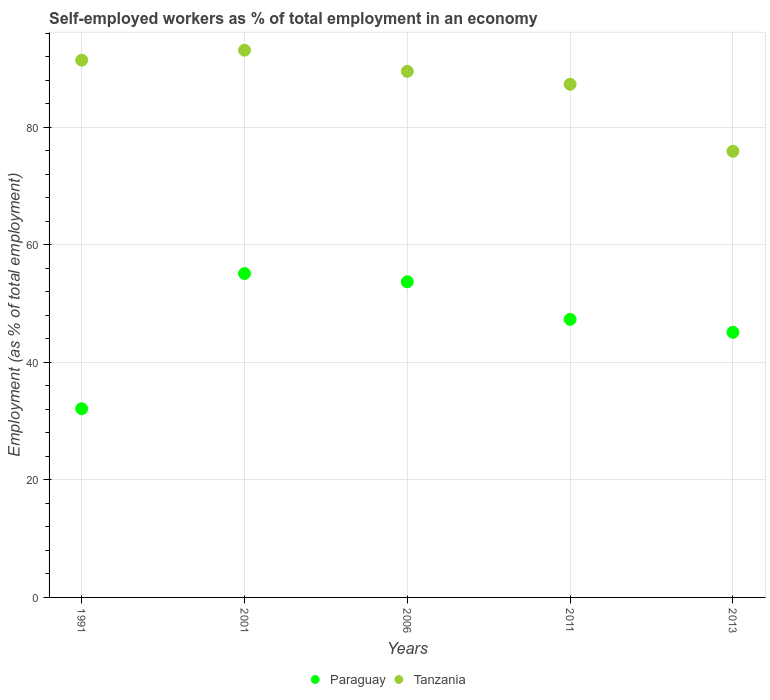Is the number of dotlines equal to the number of legend labels?
Provide a succinct answer. Yes. What is the percentage of self-employed workers in Tanzania in 2013?
Provide a succinct answer. 75.9. Across all years, what is the maximum percentage of self-employed workers in Paraguay?
Your response must be concise. 55.1. Across all years, what is the minimum percentage of self-employed workers in Paraguay?
Provide a succinct answer. 32.1. In which year was the percentage of self-employed workers in Tanzania maximum?
Keep it short and to the point. 2001. In which year was the percentage of self-employed workers in Paraguay minimum?
Make the answer very short. 1991. What is the total percentage of self-employed workers in Tanzania in the graph?
Provide a succinct answer. 437.2. What is the difference between the percentage of self-employed workers in Paraguay in 2011 and the percentage of self-employed workers in Tanzania in 2013?
Offer a terse response. -28.6. What is the average percentage of self-employed workers in Tanzania per year?
Your answer should be compact. 87.44. In the year 2011, what is the difference between the percentage of self-employed workers in Tanzania and percentage of self-employed workers in Paraguay?
Give a very brief answer. 40. In how many years, is the percentage of self-employed workers in Tanzania greater than 88 %?
Keep it short and to the point. 3. What is the ratio of the percentage of self-employed workers in Tanzania in 2001 to that in 2006?
Your answer should be compact. 1.04. Is the percentage of self-employed workers in Tanzania in 1991 less than that in 2013?
Your answer should be compact. No. What is the difference between the highest and the second highest percentage of self-employed workers in Tanzania?
Give a very brief answer. 1.7. What is the difference between the highest and the lowest percentage of self-employed workers in Paraguay?
Make the answer very short. 23. Is the sum of the percentage of self-employed workers in Tanzania in 2001 and 2011 greater than the maximum percentage of self-employed workers in Paraguay across all years?
Offer a very short reply. Yes. Does the percentage of self-employed workers in Paraguay monotonically increase over the years?
Ensure brevity in your answer.  No. Is the percentage of self-employed workers in Paraguay strictly greater than the percentage of self-employed workers in Tanzania over the years?
Your answer should be compact. No. Is the percentage of self-employed workers in Tanzania strictly less than the percentage of self-employed workers in Paraguay over the years?
Your answer should be compact. No. How many dotlines are there?
Ensure brevity in your answer.  2. How many years are there in the graph?
Give a very brief answer. 5. What is the difference between two consecutive major ticks on the Y-axis?
Make the answer very short. 20. Does the graph contain any zero values?
Provide a short and direct response. No. Does the graph contain grids?
Make the answer very short. Yes. How many legend labels are there?
Your answer should be compact. 2. What is the title of the graph?
Offer a very short reply. Self-employed workers as % of total employment in an economy. Does "Israel" appear as one of the legend labels in the graph?
Ensure brevity in your answer.  No. What is the label or title of the X-axis?
Make the answer very short. Years. What is the label or title of the Y-axis?
Your answer should be very brief. Employment (as % of total employment). What is the Employment (as % of total employment) in Paraguay in 1991?
Ensure brevity in your answer.  32.1. What is the Employment (as % of total employment) of Tanzania in 1991?
Provide a succinct answer. 91.4. What is the Employment (as % of total employment) of Paraguay in 2001?
Keep it short and to the point. 55.1. What is the Employment (as % of total employment) of Tanzania in 2001?
Your answer should be very brief. 93.1. What is the Employment (as % of total employment) of Paraguay in 2006?
Your answer should be very brief. 53.7. What is the Employment (as % of total employment) in Tanzania in 2006?
Provide a short and direct response. 89.5. What is the Employment (as % of total employment) of Paraguay in 2011?
Ensure brevity in your answer.  47.3. What is the Employment (as % of total employment) in Tanzania in 2011?
Your response must be concise. 87.3. What is the Employment (as % of total employment) of Paraguay in 2013?
Your response must be concise. 45.1. What is the Employment (as % of total employment) of Tanzania in 2013?
Provide a short and direct response. 75.9. Across all years, what is the maximum Employment (as % of total employment) in Paraguay?
Your answer should be very brief. 55.1. Across all years, what is the maximum Employment (as % of total employment) of Tanzania?
Your answer should be compact. 93.1. Across all years, what is the minimum Employment (as % of total employment) of Paraguay?
Give a very brief answer. 32.1. Across all years, what is the minimum Employment (as % of total employment) of Tanzania?
Make the answer very short. 75.9. What is the total Employment (as % of total employment) in Paraguay in the graph?
Make the answer very short. 233.3. What is the total Employment (as % of total employment) of Tanzania in the graph?
Offer a terse response. 437.2. What is the difference between the Employment (as % of total employment) in Paraguay in 1991 and that in 2001?
Provide a short and direct response. -23. What is the difference between the Employment (as % of total employment) in Tanzania in 1991 and that in 2001?
Keep it short and to the point. -1.7. What is the difference between the Employment (as % of total employment) in Paraguay in 1991 and that in 2006?
Your answer should be very brief. -21.6. What is the difference between the Employment (as % of total employment) of Tanzania in 1991 and that in 2006?
Provide a short and direct response. 1.9. What is the difference between the Employment (as % of total employment) of Paraguay in 1991 and that in 2011?
Your answer should be compact. -15.2. What is the difference between the Employment (as % of total employment) in Tanzania in 1991 and that in 2011?
Provide a short and direct response. 4.1. What is the difference between the Employment (as % of total employment) in Paraguay in 1991 and that in 2013?
Your answer should be very brief. -13. What is the difference between the Employment (as % of total employment) of Tanzania in 1991 and that in 2013?
Provide a succinct answer. 15.5. What is the difference between the Employment (as % of total employment) of Paraguay in 2001 and that in 2006?
Offer a terse response. 1.4. What is the difference between the Employment (as % of total employment) of Paraguay in 2001 and that in 2011?
Give a very brief answer. 7.8. What is the difference between the Employment (as % of total employment) in Tanzania in 2001 and that in 2011?
Offer a terse response. 5.8. What is the difference between the Employment (as % of total employment) of Tanzania in 2001 and that in 2013?
Your answer should be compact. 17.2. What is the difference between the Employment (as % of total employment) in Paraguay in 2006 and that in 2011?
Provide a short and direct response. 6.4. What is the difference between the Employment (as % of total employment) of Paraguay in 2006 and that in 2013?
Make the answer very short. 8.6. What is the difference between the Employment (as % of total employment) in Tanzania in 2006 and that in 2013?
Make the answer very short. 13.6. What is the difference between the Employment (as % of total employment) of Paraguay in 2011 and that in 2013?
Your response must be concise. 2.2. What is the difference between the Employment (as % of total employment) in Paraguay in 1991 and the Employment (as % of total employment) in Tanzania in 2001?
Your response must be concise. -61. What is the difference between the Employment (as % of total employment) in Paraguay in 1991 and the Employment (as % of total employment) in Tanzania in 2006?
Ensure brevity in your answer.  -57.4. What is the difference between the Employment (as % of total employment) of Paraguay in 1991 and the Employment (as % of total employment) of Tanzania in 2011?
Offer a very short reply. -55.2. What is the difference between the Employment (as % of total employment) in Paraguay in 1991 and the Employment (as % of total employment) in Tanzania in 2013?
Provide a short and direct response. -43.8. What is the difference between the Employment (as % of total employment) of Paraguay in 2001 and the Employment (as % of total employment) of Tanzania in 2006?
Make the answer very short. -34.4. What is the difference between the Employment (as % of total employment) of Paraguay in 2001 and the Employment (as % of total employment) of Tanzania in 2011?
Offer a very short reply. -32.2. What is the difference between the Employment (as % of total employment) in Paraguay in 2001 and the Employment (as % of total employment) in Tanzania in 2013?
Provide a succinct answer. -20.8. What is the difference between the Employment (as % of total employment) of Paraguay in 2006 and the Employment (as % of total employment) of Tanzania in 2011?
Offer a very short reply. -33.6. What is the difference between the Employment (as % of total employment) of Paraguay in 2006 and the Employment (as % of total employment) of Tanzania in 2013?
Your answer should be very brief. -22.2. What is the difference between the Employment (as % of total employment) of Paraguay in 2011 and the Employment (as % of total employment) of Tanzania in 2013?
Offer a very short reply. -28.6. What is the average Employment (as % of total employment) in Paraguay per year?
Keep it short and to the point. 46.66. What is the average Employment (as % of total employment) of Tanzania per year?
Offer a very short reply. 87.44. In the year 1991, what is the difference between the Employment (as % of total employment) of Paraguay and Employment (as % of total employment) of Tanzania?
Offer a terse response. -59.3. In the year 2001, what is the difference between the Employment (as % of total employment) in Paraguay and Employment (as % of total employment) in Tanzania?
Ensure brevity in your answer.  -38. In the year 2006, what is the difference between the Employment (as % of total employment) in Paraguay and Employment (as % of total employment) in Tanzania?
Your answer should be compact. -35.8. In the year 2013, what is the difference between the Employment (as % of total employment) in Paraguay and Employment (as % of total employment) in Tanzania?
Offer a very short reply. -30.8. What is the ratio of the Employment (as % of total employment) of Paraguay in 1991 to that in 2001?
Offer a terse response. 0.58. What is the ratio of the Employment (as % of total employment) in Tanzania in 1991 to that in 2001?
Your answer should be very brief. 0.98. What is the ratio of the Employment (as % of total employment) of Paraguay in 1991 to that in 2006?
Your answer should be compact. 0.6. What is the ratio of the Employment (as % of total employment) in Tanzania in 1991 to that in 2006?
Your response must be concise. 1.02. What is the ratio of the Employment (as % of total employment) in Paraguay in 1991 to that in 2011?
Make the answer very short. 0.68. What is the ratio of the Employment (as % of total employment) of Tanzania in 1991 to that in 2011?
Ensure brevity in your answer.  1.05. What is the ratio of the Employment (as % of total employment) of Paraguay in 1991 to that in 2013?
Your answer should be very brief. 0.71. What is the ratio of the Employment (as % of total employment) of Tanzania in 1991 to that in 2013?
Provide a succinct answer. 1.2. What is the ratio of the Employment (as % of total employment) of Paraguay in 2001 to that in 2006?
Provide a short and direct response. 1.03. What is the ratio of the Employment (as % of total employment) in Tanzania in 2001 to that in 2006?
Provide a succinct answer. 1.04. What is the ratio of the Employment (as % of total employment) of Paraguay in 2001 to that in 2011?
Make the answer very short. 1.16. What is the ratio of the Employment (as % of total employment) in Tanzania in 2001 to that in 2011?
Your answer should be compact. 1.07. What is the ratio of the Employment (as % of total employment) in Paraguay in 2001 to that in 2013?
Your answer should be compact. 1.22. What is the ratio of the Employment (as % of total employment) of Tanzania in 2001 to that in 2013?
Your answer should be very brief. 1.23. What is the ratio of the Employment (as % of total employment) of Paraguay in 2006 to that in 2011?
Keep it short and to the point. 1.14. What is the ratio of the Employment (as % of total employment) of Tanzania in 2006 to that in 2011?
Your response must be concise. 1.03. What is the ratio of the Employment (as % of total employment) of Paraguay in 2006 to that in 2013?
Offer a very short reply. 1.19. What is the ratio of the Employment (as % of total employment) in Tanzania in 2006 to that in 2013?
Your response must be concise. 1.18. What is the ratio of the Employment (as % of total employment) in Paraguay in 2011 to that in 2013?
Ensure brevity in your answer.  1.05. What is the ratio of the Employment (as % of total employment) of Tanzania in 2011 to that in 2013?
Your response must be concise. 1.15. What is the difference between the highest and the second highest Employment (as % of total employment) in Tanzania?
Provide a succinct answer. 1.7. What is the difference between the highest and the lowest Employment (as % of total employment) in Paraguay?
Provide a succinct answer. 23. What is the difference between the highest and the lowest Employment (as % of total employment) in Tanzania?
Give a very brief answer. 17.2. 